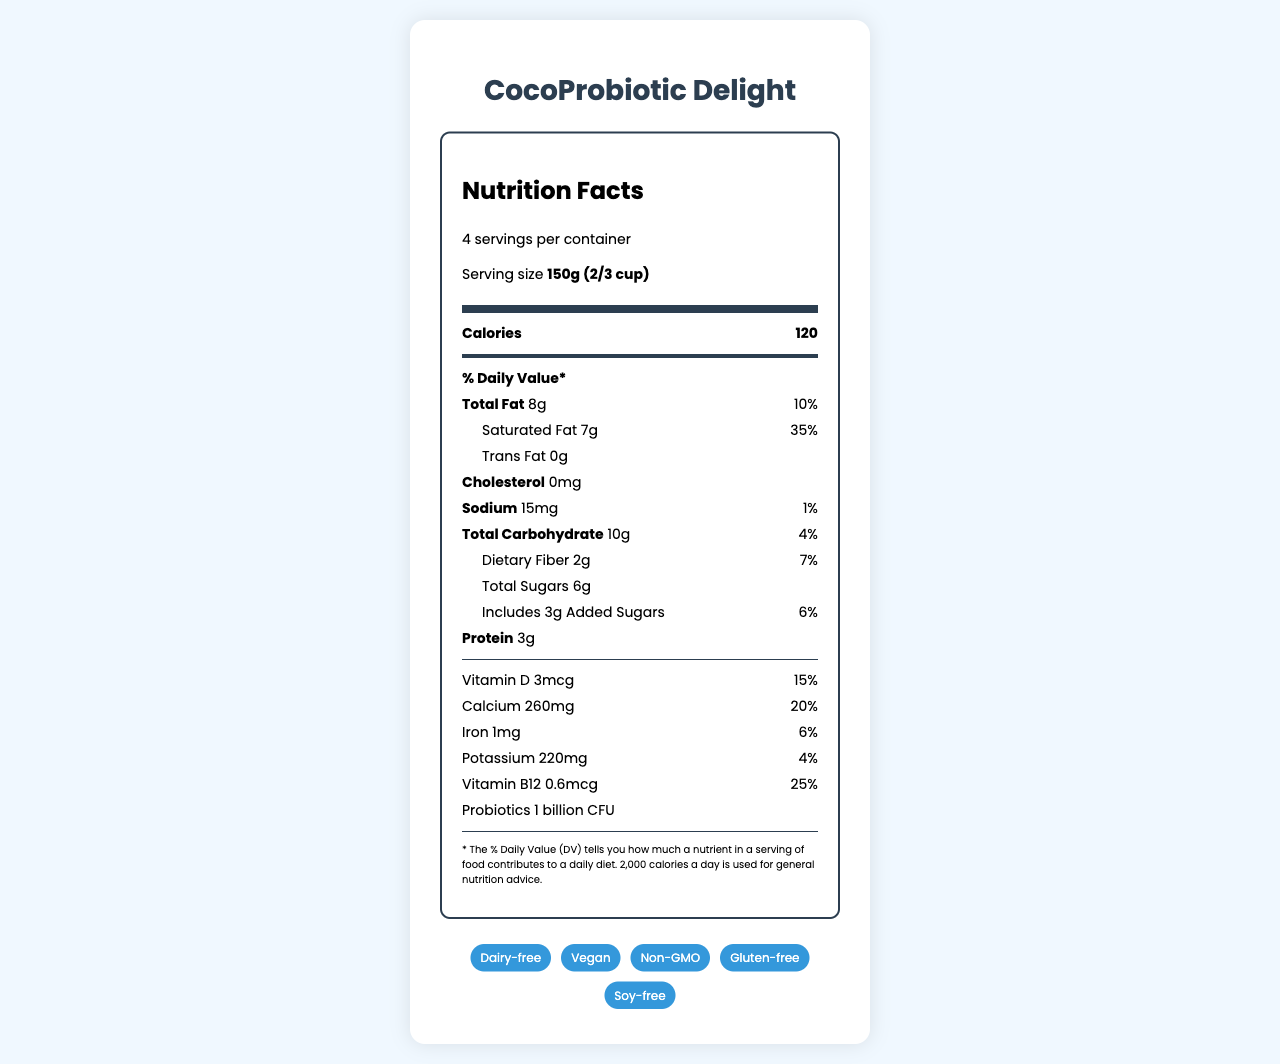What is the product name? The product name is displayed at the top of the document in the header section.
Answer: CocoProbiotic Delight What is the serving size of CocoProbiotic Delight? The serving size is mentioned under the Serving Info section.
Answer: 150g (2/3 cup) How many calories per serving does CocoProbiotic Delight have? The calorie count per serving is listed in the main info section.
Answer: 120 How much calcium is there in one serving? The calcium content per serving is specified in the nutrient section.
Answer: 260mg What percentage of the daily value for Vitamin D does one serving provide? This information is provided in the nutrient section under Vitamin D.
Answer: 15% What is the total fat content per serving? A. 8g B. 10g C. 7g D. 2g The total fat content per serving is mentioned as 8g in the nutrient section.
Answer: A Which of these claims is not associated with the product? A. Dairy-free B. Contains dairy C. Vegan D. Gluten-free The marketing claims section mentions that the product is dairy-free, vegan, and gluten-free, but it does not contain dairy.
Answer: B Does the product contain any cholesterol? The nutrient section lists the cholesterol content as 0mg.
Answer: No Describe the main nutritional highlights of CocoProbiotic Delight. The product highlights are derived from the detailed nutritional and marketing claims section.
Answer: CocoProbiotic Delight is a probiotic-rich, dairy-free yogurt alternative made from coconut milk. It is an excellent source of calcium and Vitamin D, contains no cholesterol, and has 1 billion CFU probiotics per serving. The product also carries several marketing claims such as being vegan, non-GMO, and gluten-free. Can you determine the price of the product from the document? The document does not provide any information about the price of the product.
Answer: Cannot be determined What is the percentage of saturated fat per serving? The document lists the percentage daily value of saturated fat as 35%.
Answer: 35% daily value What is the amount of dietary fiber per serving? The dietary fiber content is specified as 2g per serving in the nutrient section.
Answer: 2g How many probiotics does the product contain? The probiotics count per serving is mentioned as 1 billion CFU in the nutrient section.
Answer: 1 billion CFU What are the storage instructions for the product? The storage instructions are detailed in the Storage Instructions section.
Answer: Keep refrigerated at 35-40°F (2-4°C) What certifications does CocoProbiotic Delight have? The certifications listed are USDA Organic and Vegan Action Certified.
Answer: USDA Organic, Vegan Action Certified How many servings are there in one container? The number of servings per container is stated as 4 in the Serving Info section.
Answer: 4 Does the product contain any allergens? The allergen information mentions that the product contains coconut.
Answer: Yes, it contains coconut. Who is the manufacturer of CocoProbiotic Delight? The company information section lists NatureBite Foods as the manufacturer.
Answer: NatureBite Foods 